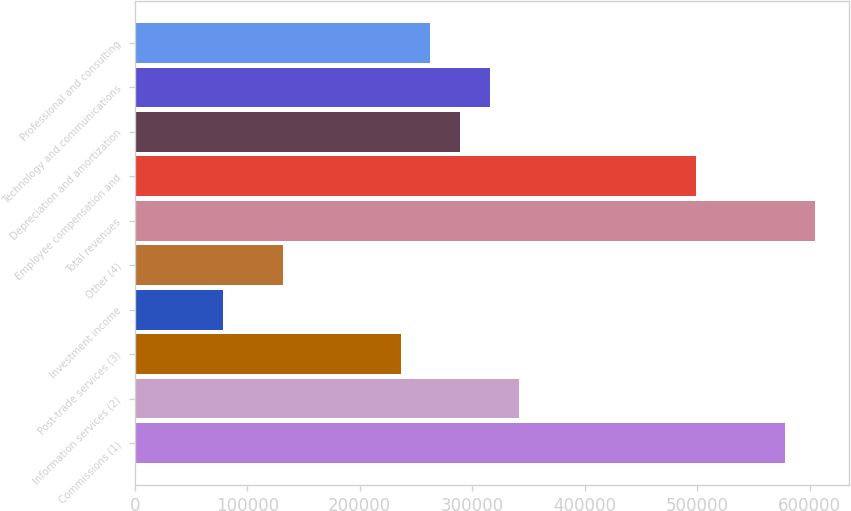<chart> <loc_0><loc_0><loc_500><loc_500><bar_chart><fcel>Commissions (1)<fcel>Information services (2)<fcel>Post-trade services (3)<fcel>Investment income<fcel>Other (4)<fcel>Total revenues<fcel>Employee compensation and<fcel>Depreciation and amortization<fcel>Technology and communications<fcel>Professional and consulting<nl><fcel>578102<fcel>341606<fcel>236497<fcel>78832.7<fcel>131387<fcel>604379<fcel>499270<fcel>289051<fcel>315329<fcel>262774<nl></chart> 